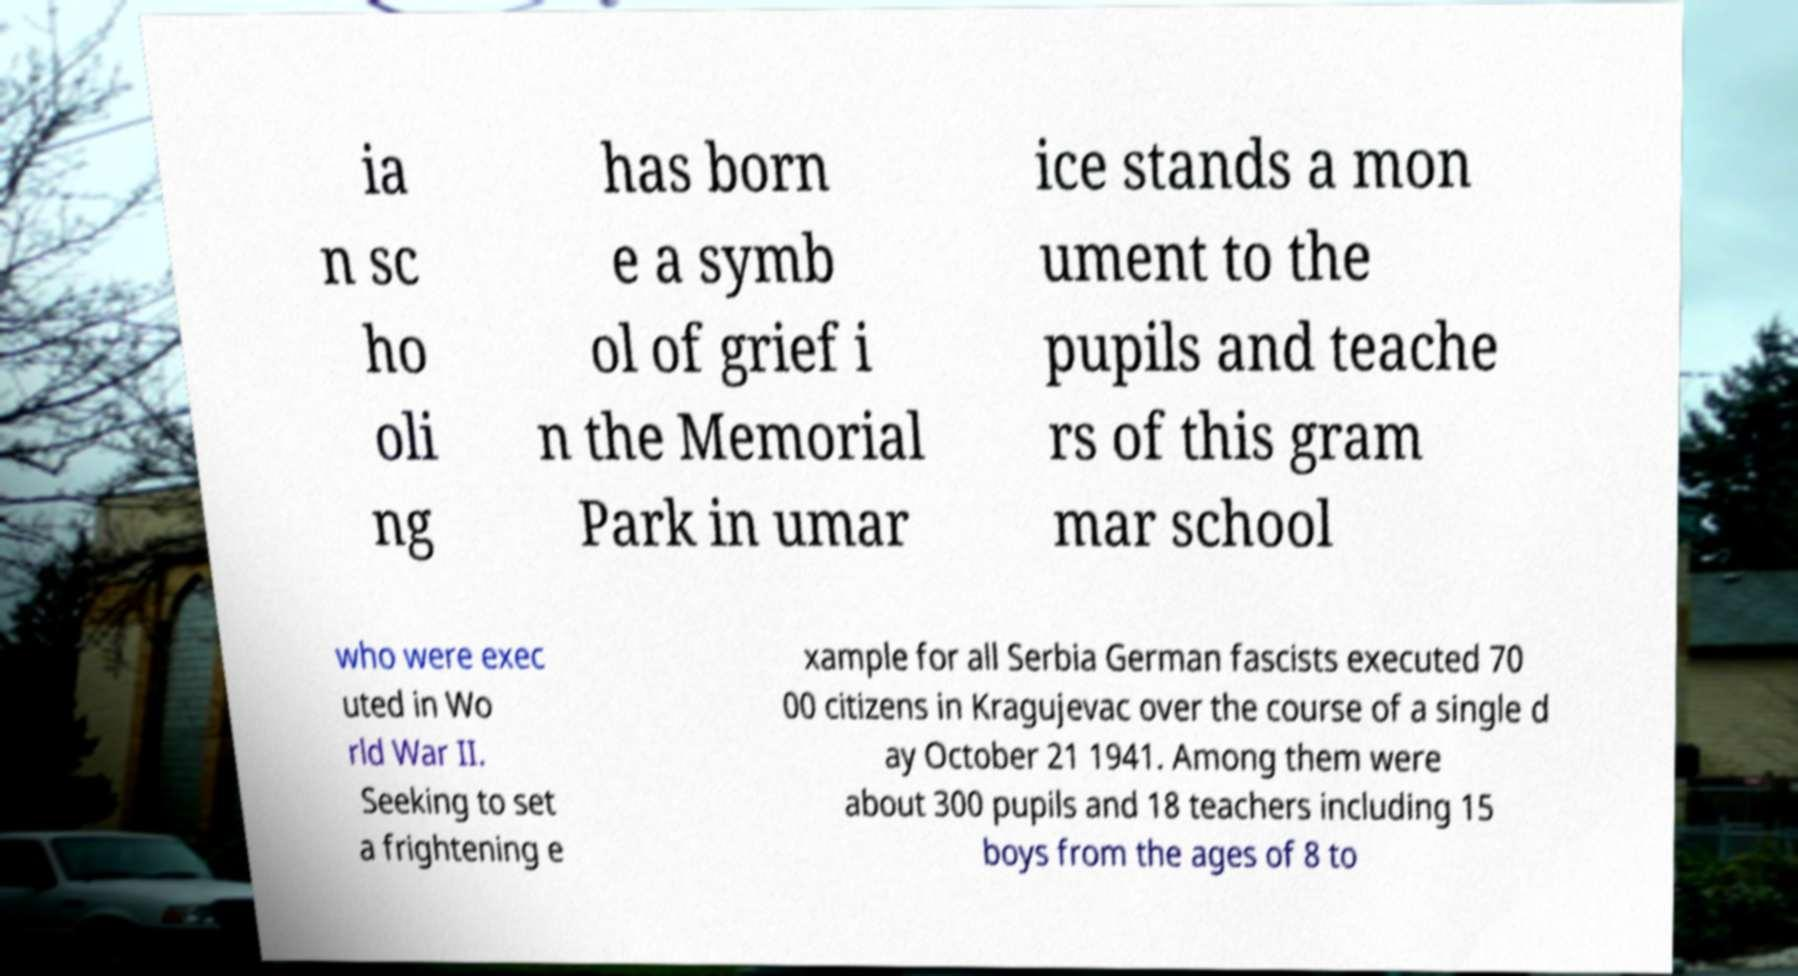Can you accurately transcribe the text from the provided image for me? ia n sc ho oli ng has born e a symb ol of grief i n the Memorial Park in umar ice stands a mon ument to the pupils and teache rs of this gram mar school who were exec uted in Wo rld War II. Seeking to set a frightening e xample for all Serbia German fascists executed 70 00 citizens in Kragujevac over the course of a single d ay October 21 1941. Among them were about 300 pupils and 18 teachers including 15 boys from the ages of 8 to 